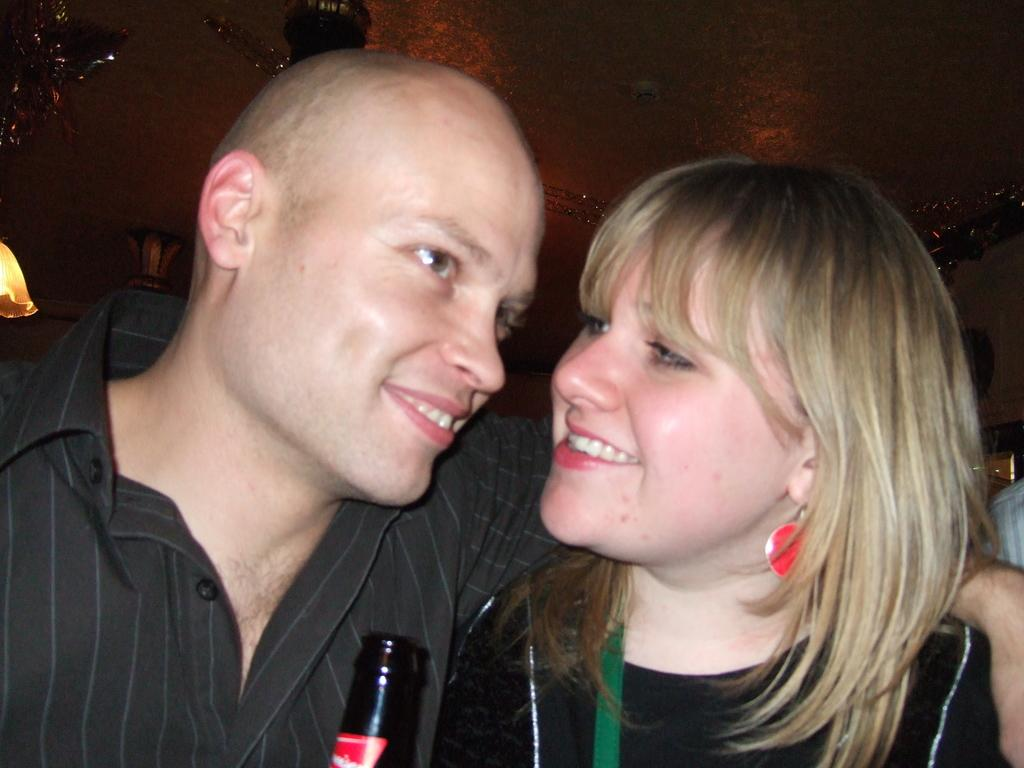Who is in the foreground of the picture? There is a couple in the foreground of the picture. What is the couple doing in the picture? The couple is smiling in the picture. What can be seen in the background of the picture? There are decorative objects and lights visible near the ceiling in the background. Can you tell me how many strangers are present in the image? There is no stranger present in the image; it features a couple. What type of van can be seen in the image? There is no van present in the image. 